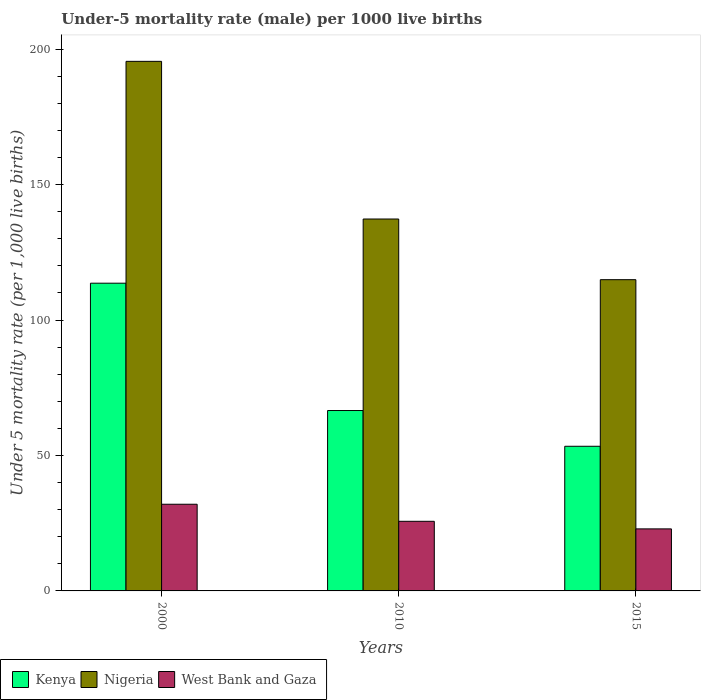How many bars are there on the 1st tick from the left?
Ensure brevity in your answer.  3. What is the label of the 2nd group of bars from the left?
Ensure brevity in your answer.  2010. What is the under-five mortality rate in Kenya in 2010?
Give a very brief answer. 66.6. Across all years, what is the minimum under-five mortality rate in Nigeria?
Give a very brief answer. 114.9. In which year was the under-five mortality rate in Kenya minimum?
Provide a short and direct response. 2015. What is the total under-five mortality rate in Kenya in the graph?
Offer a very short reply. 233.6. What is the difference between the under-five mortality rate in West Bank and Gaza in 2000 and that in 2010?
Give a very brief answer. 6.3. What is the difference between the under-five mortality rate in Nigeria in 2000 and the under-five mortality rate in Kenya in 2010?
Your answer should be very brief. 128.9. What is the average under-five mortality rate in Nigeria per year?
Your response must be concise. 149.23. In the year 2015, what is the difference between the under-five mortality rate in Kenya and under-five mortality rate in West Bank and Gaza?
Ensure brevity in your answer.  30.5. In how many years, is the under-five mortality rate in Kenya greater than 120?
Give a very brief answer. 0. What is the ratio of the under-five mortality rate in West Bank and Gaza in 2000 to that in 2015?
Provide a succinct answer. 1.4. What is the difference between the highest and the second highest under-five mortality rate in Kenya?
Offer a very short reply. 47. What is the difference between the highest and the lowest under-five mortality rate in Nigeria?
Your answer should be very brief. 80.6. In how many years, is the under-five mortality rate in West Bank and Gaza greater than the average under-five mortality rate in West Bank and Gaza taken over all years?
Give a very brief answer. 1. What does the 1st bar from the left in 2010 represents?
Provide a succinct answer. Kenya. What does the 3rd bar from the right in 2010 represents?
Your answer should be very brief. Kenya. Are all the bars in the graph horizontal?
Your response must be concise. No. How many years are there in the graph?
Your response must be concise. 3. Does the graph contain any zero values?
Your answer should be compact. No. Where does the legend appear in the graph?
Provide a succinct answer. Bottom left. How are the legend labels stacked?
Your answer should be compact. Horizontal. What is the title of the graph?
Your response must be concise. Under-5 mortality rate (male) per 1000 live births. What is the label or title of the Y-axis?
Offer a very short reply. Under 5 mortality rate (per 1,0 live births). What is the Under 5 mortality rate (per 1,000 live births) of Kenya in 2000?
Provide a short and direct response. 113.6. What is the Under 5 mortality rate (per 1,000 live births) of Nigeria in 2000?
Provide a short and direct response. 195.5. What is the Under 5 mortality rate (per 1,000 live births) in West Bank and Gaza in 2000?
Ensure brevity in your answer.  32. What is the Under 5 mortality rate (per 1,000 live births) of Kenya in 2010?
Offer a terse response. 66.6. What is the Under 5 mortality rate (per 1,000 live births) in Nigeria in 2010?
Provide a succinct answer. 137.3. What is the Under 5 mortality rate (per 1,000 live births) in West Bank and Gaza in 2010?
Your response must be concise. 25.7. What is the Under 5 mortality rate (per 1,000 live births) in Kenya in 2015?
Provide a succinct answer. 53.4. What is the Under 5 mortality rate (per 1,000 live births) in Nigeria in 2015?
Make the answer very short. 114.9. What is the Under 5 mortality rate (per 1,000 live births) in West Bank and Gaza in 2015?
Offer a terse response. 22.9. Across all years, what is the maximum Under 5 mortality rate (per 1,000 live births) in Kenya?
Keep it short and to the point. 113.6. Across all years, what is the maximum Under 5 mortality rate (per 1,000 live births) of Nigeria?
Make the answer very short. 195.5. Across all years, what is the maximum Under 5 mortality rate (per 1,000 live births) of West Bank and Gaza?
Make the answer very short. 32. Across all years, what is the minimum Under 5 mortality rate (per 1,000 live births) of Kenya?
Offer a terse response. 53.4. Across all years, what is the minimum Under 5 mortality rate (per 1,000 live births) of Nigeria?
Your answer should be compact. 114.9. Across all years, what is the minimum Under 5 mortality rate (per 1,000 live births) in West Bank and Gaza?
Offer a terse response. 22.9. What is the total Under 5 mortality rate (per 1,000 live births) of Kenya in the graph?
Make the answer very short. 233.6. What is the total Under 5 mortality rate (per 1,000 live births) of Nigeria in the graph?
Keep it short and to the point. 447.7. What is the total Under 5 mortality rate (per 1,000 live births) of West Bank and Gaza in the graph?
Your response must be concise. 80.6. What is the difference between the Under 5 mortality rate (per 1,000 live births) in Kenya in 2000 and that in 2010?
Give a very brief answer. 47. What is the difference between the Under 5 mortality rate (per 1,000 live births) in Nigeria in 2000 and that in 2010?
Your response must be concise. 58.2. What is the difference between the Under 5 mortality rate (per 1,000 live births) of West Bank and Gaza in 2000 and that in 2010?
Offer a very short reply. 6.3. What is the difference between the Under 5 mortality rate (per 1,000 live births) of Kenya in 2000 and that in 2015?
Your answer should be very brief. 60.2. What is the difference between the Under 5 mortality rate (per 1,000 live births) of Nigeria in 2000 and that in 2015?
Keep it short and to the point. 80.6. What is the difference between the Under 5 mortality rate (per 1,000 live births) in Nigeria in 2010 and that in 2015?
Ensure brevity in your answer.  22.4. What is the difference between the Under 5 mortality rate (per 1,000 live births) of West Bank and Gaza in 2010 and that in 2015?
Make the answer very short. 2.8. What is the difference between the Under 5 mortality rate (per 1,000 live births) in Kenya in 2000 and the Under 5 mortality rate (per 1,000 live births) in Nigeria in 2010?
Keep it short and to the point. -23.7. What is the difference between the Under 5 mortality rate (per 1,000 live births) in Kenya in 2000 and the Under 5 mortality rate (per 1,000 live births) in West Bank and Gaza in 2010?
Provide a short and direct response. 87.9. What is the difference between the Under 5 mortality rate (per 1,000 live births) of Nigeria in 2000 and the Under 5 mortality rate (per 1,000 live births) of West Bank and Gaza in 2010?
Offer a very short reply. 169.8. What is the difference between the Under 5 mortality rate (per 1,000 live births) of Kenya in 2000 and the Under 5 mortality rate (per 1,000 live births) of Nigeria in 2015?
Your answer should be compact. -1.3. What is the difference between the Under 5 mortality rate (per 1,000 live births) in Kenya in 2000 and the Under 5 mortality rate (per 1,000 live births) in West Bank and Gaza in 2015?
Offer a terse response. 90.7. What is the difference between the Under 5 mortality rate (per 1,000 live births) of Nigeria in 2000 and the Under 5 mortality rate (per 1,000 live births) of West Bank and Gaza in 2015?
Keep it short and to the point. 172.6. What is the difference between the Under 5 mortality rate (per 1,000 live births) in Kenya in 2010 and the Under 5 mortality rate (per 1,000 live births) in Nigeria in 2015?
Give a very brief answer. -48.3. What is the difference between the Under 5 mortality rate (per 1,000 live births) of Kenya in 2010 and the Under 5 mortality rate (per 1,000 live births) of West Bank and Gaza in 2015?
Offer a very short reply. 43.7. What is the difference between the Under 5 mortality rate (per 1,000 live births) in Nigeria in 2010 and the Under 5 mortality rate (per 1,000 live births) in West Bank and Gaza in 2015?
Keep it short and to the point. 114.4. What is the average Under 5 mortality rate (per 1,000 live births) of Kenya per year?
Offer a terse response. 77.87. What is the average Under 5 mortality rate (per 1,000 live births) of Nigeria per year?
Keep it short and to the point. 149.23. What is the average Under 5 mortality rate (per 1,000 live births) in West Bank and Gaza per year?
Make the answer very short. 26.87. In the year 2000, what is the difference between the Under 5 mortality rate (per 1,000 live births) in Kenya and Under 5 mortality rate (per 1,000 live births) in Nigeria?
Provide a succinct answer. -81.9. In the year 2000, what is the difference between the Under 5 mortality rate (per 1,000 live births) in Kenya and Under 5 mortality rate (per 1,000 live births) in West Bank and Gaza?
Your response must be concise. 81.6. In the year 2000, what is the difference between the Under 5 mortality rate (per 1,000 live births) of Nigeria and Under 5 mortality rate (per 1,000 live births) of West Bank and Gaza?
Your answer should be very brief. 163.5. In the year 2010, what is the difference between the Under 5 mortality rate (per 1,000 live births) of Kenya and Under 5 mortality rate (per 1,000 live births) of Nigeria?
Make the answer very short. -70.7. In the year 2010, what is the difference between the Under 5 mortality rate (per 1,000 live births) in Kenya and Under 5 mortality rate (per 1,000 live births) in West Bank and Gaza?
Your answer should be compact. 40.9. In the year 2010, what is the difference between the Under 5 mortality rate (per 1,000 live births) in Nigeria and Under 5 mortality rate (per 1,000 live births) in West Bank and Gaza?
Offer a terse response. 111.6. In the year 2015, what is the difference between the Under 5 mortality rate (per 1,000 live births) of Kenya and Under 5 mortality rate (per 1,000 live births) of Nigeria?
Offer a terse response. -61.5. In the year 2015, what is the difference between the Under 5 mortality rate (per 1,000 live births) in Kenya and Under 5 mortality rate (per 1,000 live births) in West Bank and Gaza?
Provide a succinct answer. 30.5. In the year 2015, what is the difference between the Under 5 mortality rate (per 1,000 live births) of Nigeria and Under 5 mortality rate (per 1,000 live births) of West Bank and Gaza?
Offer a very short reply. 92. What is the ratio of the Under 5 mortality rate (per 1,000 live births) of Kenya in 2000 to that in 2010?
Your answer should be very brief. 1.71. What is the ratio of the Under 5 mortality rate (per 1,000 live births) of Nigeria in 2000 to that in 2010?
Your answer should be very brief. 1.42. What is the ratio of the Under 5 mortality rate (per 1,000 live births) of West Bank and Gaza in 2000 to that in 2010?
Your answer should be compact. 1.25. What is the ratio of the Under 5 mortality rate (per 1,000 live births) in Kenya in 2000 to that in 2015?
Your answer should be compact. 2.13. What is the ratio of the Under 5 mortality rate (per 1,000 live births) in Nigeria in 2000 to that in 2015?
Keep it short and to the point. 1.7. What is the ratio of the Under 5 mortality rate (per 1,000 live births) of West Bank and Gaza in 2000 to that in 2015?
Ensure brevity in your answer.  1.4. What is the ratio of the Under 5 mortality rate (per 1,000 live births) in Kenya in 2010 to that in 2015?
Keep it short and to the point. 1.25. What is the ratio of the Under 5 mortality rate (per 1,000 live births) of Nigeria in 2010 to that in 2015?
Provide a succinct answer. 1.2. What is the ratio of the Under 5 mortality rate (per 1,000 live births) of West Bank and Gaza in 2010 to that in 2015?
Give a very brief answer. 1.12. What is the difference between the highest and the second highest Under 5 mortality rate (per 1,000 live births) in Kenya?
Make the answer very short. 47. What is the difference between the highest and the second highest Under 5 mortality rate (per 1,000 live births) in Nigeria?
Ensure brevity in your answer.  58.2. What is the difference between the highest and the second highest Under 5 mortality rate (per 1,000 live births) of West Bank and Gaza?
Your response must be concise. 6.3. What is the difference between the highest and the lowest Under 5 mortality rate (per 1,000 live births) in Kenya?
Provide a short and direct response. 60.2. What is the difference between the highest and the lowest Under 5 mortality rate (per 1,000 live births) in Nigeria?
Your response must be concise. 80.6. 